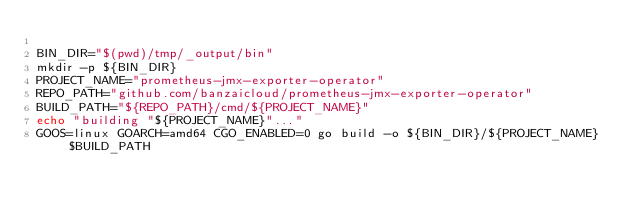Convert code to text. <code><loc_0><loc_0><loc_500><loc_500><_Bash_>
BIN_DIR="$(pwd)/tmp/_output/bin"
mkdir -p ${BIN_DIR}
PROJECT_NAME="prometheus-jmx-exporter-operator"
REPO_PATH="github.com/banzaicloud/prometheus-jmx-exporter-operator"
BUILD_PATH="${REPO_PATH}/cmd/${PROJECT_NAME}"
echo "building "${PROJECT_NAME}"..."
GOOS=linux GOARCH=amd64 CGO_ENABLED=0 go build -o ${BIN_DIR}/${PROJECT_NAME} $BUILD_PATH
</code> 